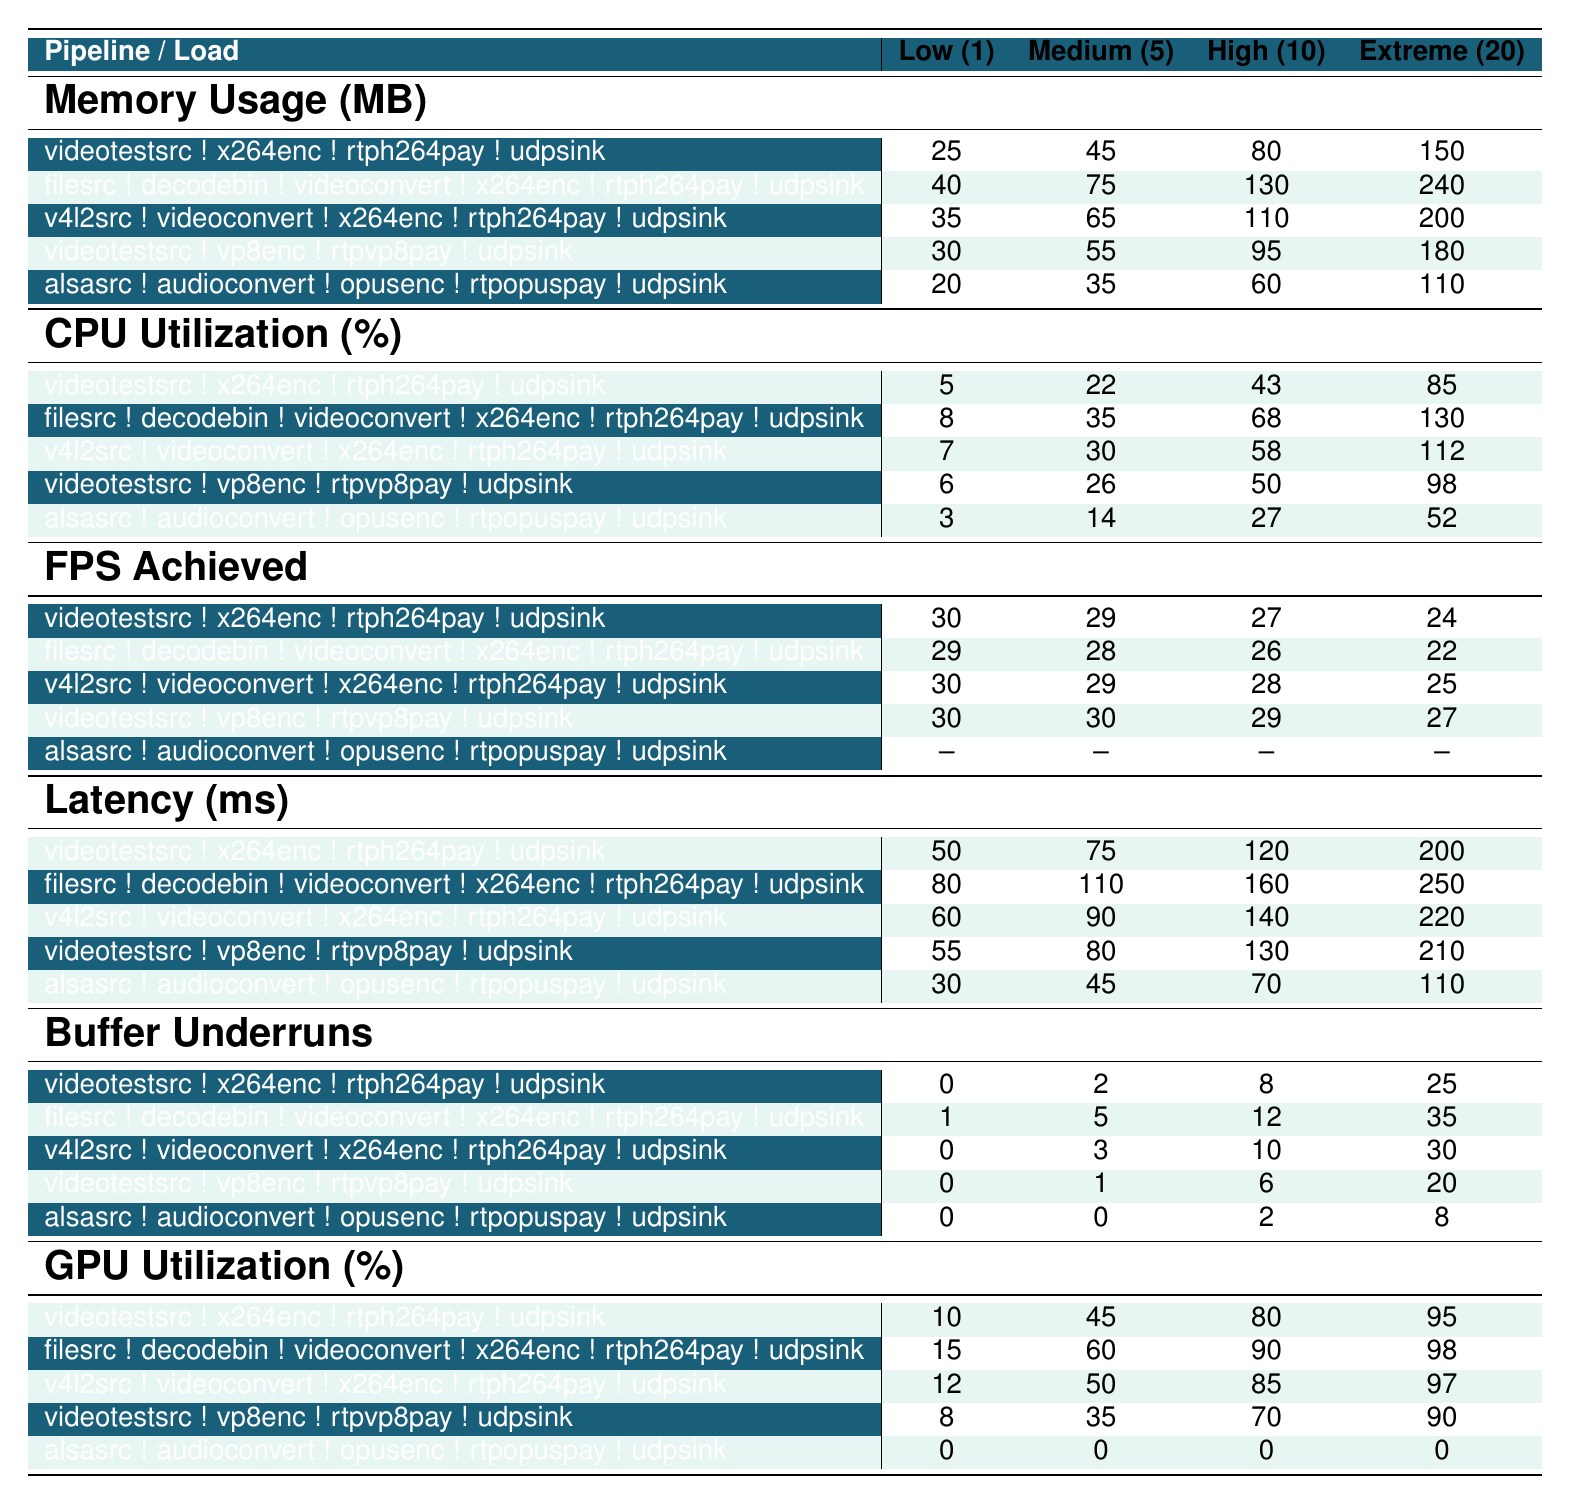What is the maximum CPU utilization for the pipeline using 'filesrc'? Looking at the CPU utilization row for the 'filesrc' pipeline, the highest value appears under the 'Extreme (20 streams)' column, which is 130%.
Answer: 130% What is the memory usage for 'v4l2src' under 'Medium (5 streams)' condition? The memory usage for the 'v4l2src' pipeline under the 'Medium (5 streams)' column is 65 MB.
Answer: 65 MB Does the 'alsasrc' pipeline have any GPU utilization? Referring to the GPU utilization row for the 'alsasrc' pipeline, all entries are 0, indicating that there is no GPU utilization.
Answer: No What is the average latency for the pipeline using 'videotestsrc' across all load scenarios? The latency values for 'videotestsrc' are 50, 75, 120, and 200 ms. The average is calculated as (50 + 75 + 120 + 200) / 4 = 111.25 ms, which can be rounded to 111 ms.
Answer: 111 ms Which pipeline exhibits the highest buffer underruns under 'Extreme (20 streams)'? Checking the buffer underruns for all pipelines under 'Extreme (20 streams)', the 'filesrc' pipeline has the highest at 35.
Answer: 35 What percentage increase in memory usage does 'videotestsrc ! x264enc ! rtph264pay ! udpsink' show when moving from 'Low (1 stream)' to 'Extreme (20 streams)'? For 'videotestsrc ! x264enc ! rtph264pay ! udpsink', the memory usage increases from 25 MB under 'Low (1 stream)' to 150 MB under 'Extreme (20 streams)'. The increase is (150 - 25) / 25 * 100% = 500%.
Answer: 500% How does the FPS achieved change from 'Medium (5 streams)' to 'High (10 streams)' for 'filesrc'? The FPS achieved for 'filesrc' is 28 under 'Medium (5 streams)' and decreases to 26 under 'High (10 streams)'. The change is a decrease of 2 frames per second.
Answer: 2 FPS decrease Is there a correlation between CPU utilization and memory usage as seen in the table? Analyzing the table, higher memory usage generally corresponds with higher CPU utilization across different pipelines and load conditions. For instance, when memory usage for 'filesrc' increases from 75 MB to 130 MB, CPU utilization also increases from 35% to 68%. This indicates a positive correlation.
Answer: Yes, there is a correlation 